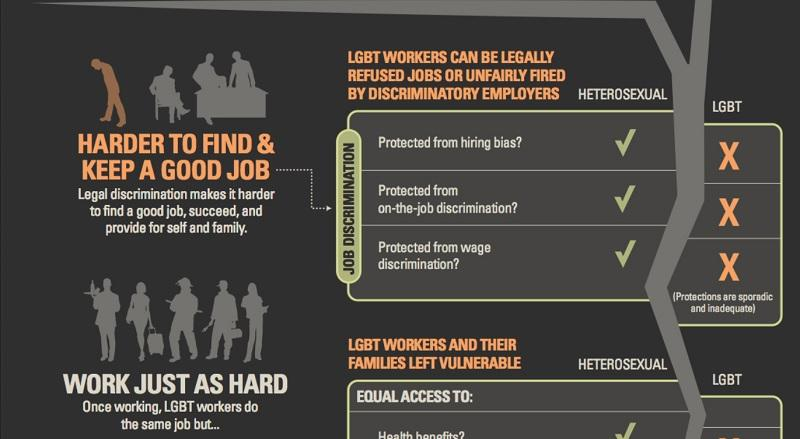Highlight a few significant elements in this photo. There are three areas in which LGBT individuals frequently experience job discrimination. Two types of gender are considered in job discrimination, which are heterosexual and LGBT. 